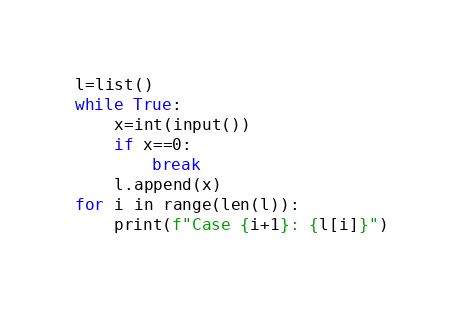<code> <loc_0><loc_0><loc_500><loc_500><_Python_>l=list()
while True:
    x=int(input())
    if x==0:
        break
    l.append(x)
for i in range(len(l)):
    print(f"Case {i+1}: {l[i]}")

</code> 